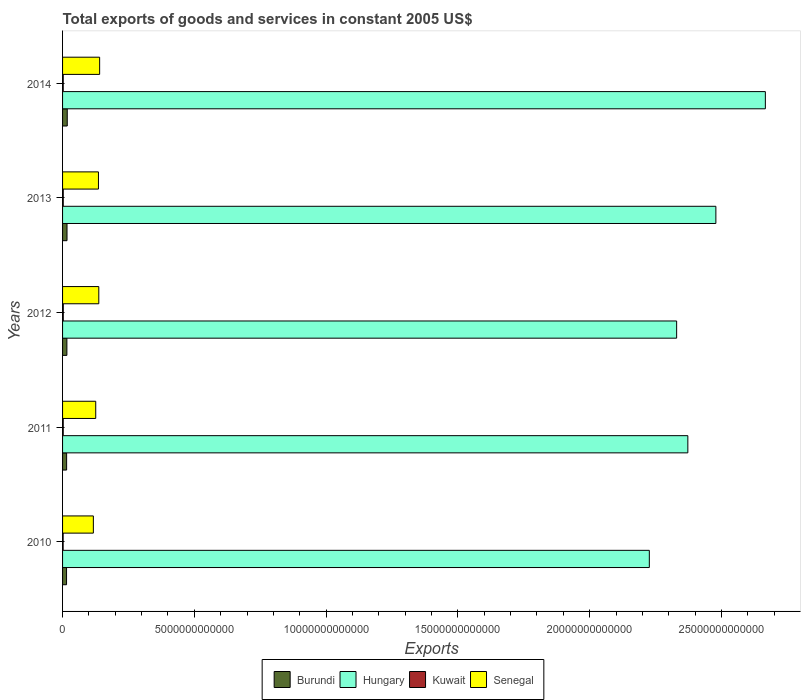How many different coloured bars are there?
Keep it short and to the point. 4. How many groups of bars are there?
Your answer should be compact. 5. Are the number of bars per tick equal to the number of legend labels?
Ensure brevity in your answer.  Yes. Are the number of bars on each tick of the Y-axis equal?
Your answer should be compact. Yes. How many bars are there on the 4th tick from the top?
Keep it short and to the point. 4. What is the label of the 1st group of bars from the top?
Offer a very short reply. 2014. In how many cases, is the number of bars for a given year not equal to the number of legend labels?
Provide a short and direct response. 0. What is the total exports of goods and services in Hungary in 2013?
Your answer should be compact. 2.48e+13. Across all years, what is the maximum total exports of goods and services in Hungary?
Offer a very short reply. 2.67e+13. Across all years, what is the minimum total exports of goods and services in Burundi?
Offer a terse response. 1.51e+11. In which year was the total exports of goods and services in Burundi maximum?
Offer a terse response. 2014. What is the total total exports of goods and services in Hungary in the graph?
Your response must be concise. 1.21e+14. What is the difference between the total exports of goods and services in Hungary in 2012 and that in 2014?
Provide a short and direct response. -3.37e+12. What is the difference between the total exports of goods and services in Burundi in 2011 and the total exports of goods and services in Hungary in 2013?
Offer a terse response. -2.46e+13. What is the average total exports of goods and services in Burundi per year?
Provide a succinct answer. 1.63e+11. In the year 2013, what is the difference between the total exports of goods and services in Burundi and total exports of goods and services in Hungary?
Provide a succinct answer. -2.46e+13. What is the ratio of the total exports of goods and services in Hungary in 2011 to that in 2012?
Offer a very short reply. 1.02. What is the difference between the highest and the second highest total exports of goods and services in Kuwait?
Offer a terse response. 1.08e+09. What is the difference between the highest and the lowest total exports of goods and services in Hungary?
Offer a very short reply. 4.40e+12. In how many years, is the total exports of goods and services in Hungary greater than the average total exports of goods and services in Hungary taken over all years?
Offer a terse response. 2. Is the sum of the total exports of goods and services in Burundi in 2012 and 2014 greater than the maximum total exports of goods and services in Senegal across all years?
Your answer should be very brief. No. Is it the case that in every year, the sum of the total exports of goods and services in Burundi and total exports of goods and services in Senegal is greater than the sum of total exports of goods and services in Hungary and total exports of goods and services in Kuwait?
Provide a short and direct response. No. What does the 3rd bar from the top in 2011 represents?
Your response must be concise. Hungary. What does the 4th bar from the bottom in 2013 represents?
Your answer should be compact. Senegal. How many bars are there?
Your answer should be very brief. 20. Are all the bars in the graph horizontal?
Provide a succinct answer. Yes. What is the difference between two consecutive major ticks on the X-axis?
Ensure brevity in your answer.  5.00e+12. Does the graph contain any zero values?
Offer a terse response. No. Does the graph contain grids?
Keep it short and to the point. No. Where does the legend appear in the graph?
Provide a short and direct response. Bottom center. What is the title of the graph?
Offer a terse response. Total exports of goods and services in constant 2005 US$. What is the label or title of the X-axis?
Your answer should be compact. Exports. What is the label or title of the Y-axis?
Your response must be concise. Years. What is the Exports in Burundi in 2010?
Provide a succinct answer. 1.51e+11. What is the Exports of Hungary in 2010?
Offer a terse response. 2.23e+13. What is the Exports in Kuwait in 2010?
Give a very brief answer. 2.21e+1. What is the Exports in Senegal in 2010?
Offer a very short reply. 1.17e+12. What is the Exports in Burundi in 2011?
Offer a terse response. 1.54e+11. What is the Exports of Hungary in 2011?
Offer a terse response. 2.37e+13. What is the Exports of Kuwait in 2011?
Make the answer very short. 2.52e+1. What is the Exports in Senegal in 2011?
Offer a very short reply. 1.26e+12. What is the Exports of Burundi in 2012?
Your answer should be very brief. 1.64e+11. What is the Exports in Hungary in 2012?
Your answer should be very brief. 2.33e+13. What is the Exports in Kuwait in 2012?
Offer a very short reply. 2.71e+1. What is the Exports in Senegal in 2012?
Keep it short and to the point. 1.37e+12. What is the Exports in Burundi in 2013?
Make the answer very short. 1.69e+11. What is the Exports of Hungary in 2013?
Keep it short and to the point. 2.48e+13. What is the Exports in Kuwait in 2013?
Your answer should be compact. 2.61e+1. What is the Exports in Senegal in 2013?
Your answer should be compact. 1.36e+12. What is the Exports in Burundi in 2014?
Give a very brief answer. 1.78e+11. What is the Exports in Hungary in 2014?
Give a very brief answer. 2.67e+13. What is the Exports of Kuwait in 2014?
Your answer should be compact. 2.52e+1. What is the Exports in Senegal in 2014?
Make the answer very short. 1.41e+12. Across all years, what is the maximum Exports of Burundi?
Your answer should be compact. 1.78e+11. Across all years, what is the maximum Exports of Hungary?
Your response must be concise. 2.67e+13. Across all years, what is the maximum Exports in Kuwait?
Ensure brevity in your answer.  2.71e+1. Across all years, what is the maximum Exports in Senegal?
Offer a terse response. 1.41e+12. Across all years, what is the minimum Exports in Burundi?
Your answer should be compact. 1.51e+11. Across all years, what is the minimum Exports in Hungary?
Give a very brief answer. 2.23e+13. Across all years, what is the minimum Exports of Kuwait?
Make the answer very short. 2.21e+1. Across all years, what is the minimum Exports in Senegal?
Provide a short and direct response. 1.17e+12. What is the total Exports in Burundi in the graph?
Offer a very short reply. 8.16e+11. What is the total Exports of Hungary in the graph?
Provide a short and direct response. 1.21e+14. What is the total Exports of Kuwait in the graph?
Provide a short and direct response. 1.26e+11. What is the total Exports in Senegal in the graph?
Provide a succinct answer. 6.57e+12. What is the difference between the Exports in Burundi in 2010 and that in 2011?
Your response must be concise. -2.64e+09. What is the difference between the Exports in Hungary in 2010 and that in 2011?
Your response must be concise. -1.46e+12. What is the difference between the Exports of Kuwait in 2010 and that in 2011?
Ensure brevity in your answer.  -3.15e+09. What is the difference between the Exports in Senegal in 2010 and that in 2011?
Offer a terse response. -9.03e+1. What is the difference between the Exports in Burundi in 2010 and that in 2012?
Provide a succinct answer. -1.28e+1. What is the difference between the Exports in Hungary in 2010 and that in 2012?
Provide a succinct answer. -1.04e+12. What is the difference between the Exports in Kuwait in 2010 and that in 2012?
Give a very brief answer. -5.08e+09. What is the difference between the Exports in Senegal in 2010 and that in 2012?
Offer a very short reply. -2.06e+11. What is the difference between the Exports of Burundi in 2010 and that in 2013?
Offer a very short reply. -1.77e+1. What is the difference between the Exports in Hungary in 2010 and that in 2013?
Keep it short and to the point. -2.52e+12. What is the difference between the Exports in Kuwait in 2010 and that in 2013?
Offer a terse response. -4.00e+09. What is the difference between the Exports of Senegal in 2010 and that in 2013?
Your response must be concise. -1.93e+11. What is the difference between the Exports in Burundi in 2010 and that in 2014?
Keep it short and to the point. -2.68e+1. What is the difference between the Exports in Hungary in 2010 and that in 2014?
Offer a terse response. -4.40e+12. What is the difference between the Exports of Kuwait in 2010 and that in 2014?
Your answer should be very brief. -3.19e+09. What is the difference between the Exports of Senegal in 2010 and that in 2014?
Your answer should be compact. -2.38e+11. What is the difference between the Exports in Burundi in 2011 and that in 2012?
Ensure brevity in your answer.  -1.01e+1. What is the difference between the Exports of Hungary in 2011 and that in 2012?
Ensure brevity in your answer.  4.25e+11. What is the difference between the Exports of Kuwait in 2011 and that in 2012?
Make the answer very short. -1.94e+09. What is the difference between the Exports of Senegal in 2011 and that in 2012?
Provide a succinct answer. -1.16e+11. What is the difference between the Exports of Burundi in 2011 and that in 2013?
Make the answer very short. -1.50e+1. What is the difference between the Exports in Hungary in 2011 and that in 2013?
Your answer should be compact. -1.06e+12. What is the difference between the Exports in Kuwait in 2011 and that in 2013?
Your response must be concise. -8.54e+08. What is the difference between the Exports of Senegal in 2011 and that in 2013?
Offer a terse response. -1.03e+11. What is the difference between the Exports of Burundi in 2011 and that in 2014?
Give a very brief answer. -2.41e+1. What is the difference between the Exports in Hungary in 2011 and that in 2014?
Provide a short and direct response. -2.94e+12. What is the difference between the Exports in Kuwait in 2011 and that in 2014?
Offer a terse response. -4.82e+07. What is the difference between the Exports in Senegal in 2011 and that in 2014?
Ensure brevity in your answer.  -1.48e+11. What is the difference between the Exports of Burundi in 2012 and that in 2013?
Give a very brief answer. -4.92e+09. What is the difference between the Exports in Hungary in 2012 and that in 2013?
Ensure brevity in your answer.  -1.49e+12. What is the difference between the Exports in Kuwait in 2012 and that in 2013?
Offer a terse response. 1.08e+09. What is the difference between the Exports in Senegal in 2012 and that in 2013?
Offer a terse response. 1.33e+1. What is the difference between the Exports of Burundi in 2012 and that in 2014?
Give a very brief answer. -1.40e+1. What is the difference between the Exports of Hungary in 2012 and that in 2014?
Offer a very short reply. -3.37e+12. What is the difference between the Exports in Kuwait in 2012 and that in 2014?
Offer a terse response. 1.89e+09. What is the difference between the Exports in Senegal in 2012 and that in 2014?
Provide a succinct answer. -3.16e+1. What is the difference between the Exports of Burundi in 2013 and that in 2014?
Your response must be concise. -9.08e+09. What is the difference between the Exports in Hungary in 2013 and that in 2014?
Make the answer very short. -1.88e+12. What is the difference between the Exports in Kuwait in 2013 and that in 2014?
Your answer should be compact. 8.05e+08. What is the difference between the Exports in Senegal in 2013 and that in 2014?
Your answer should be very brief. -4.50e+1. What is the difference between the Exports of Burundi in 2010 and the Exports of Hungary in 2011?
Your answer should be very brief. -2.36e+13. What is the difference between the Exports of Burundi in 2010 and the Exports of Kuwait in 2011?
Your answer should be very brief. 1.26e+11. What is the difference between the Exports in Burundi in 2010 and the Exports in Senegal in 2011?
Provide a short and direct response. -1.11e+12. What is the difference between the Exports of Hungary in 2010 and the Exports of Kuwait in 2011?
Make the answer very short. 2.22e+13. What is the difference between the Exports in Hungary in 2010 and the Exports in Senegal in 2011?
Your answer should be very brief. 2.10e+13. What is the difference between the Exports of Kuwait in 2010 and the Exports of Senegal in 2011?
Give a very brief answer. -1.24e+12. What is the difference between the Exports in Burundi in 2010 and the Exports in Hungary in 2012?
Offer a terse response. -2.31e+13. What is the difference between the Exports in Burundi in 2010 and the Exports in Kuwait in 2012?
Your response must be concise. 1.24e+11. What is the difference between the Exports of Burundi in 2010 and the Exports of Senegal in 2012?
Ensure brevity in your answer.  -1.22e+12. What is the difference between the Exports in Hungary in 2010 and the Exports in Kuwait in 2012?
Provide a short and direct response. 2.22e+13. What is the difference between the Exports of Hungary in 2010 and the Exports of Senegal in 2012?
Make the answer very short. 2.09e+13. What is the difference between the Exports of Kuwait in 2010 and the Exports of Senegal in 2012?
Your answer should be compact. -1.35e+12. What is the difference between the Exports of Burundi in 2010 and the Exports of Hungary in 2013?
Offer a very short reply. -2.46e+13. What is the difference between the Exports of Burundi in 2010 and the Exports of Kuwait in 2013?
Offer a terse response. 1.25e+11. What is the difference between the Exports of Burundi in 2010 and the Exports of Senegal in 2013?
Keep it short and to the point. -1.21e+12. What is the difference between the Exports in Hungary in 2010 and the Exports in Kuwait in 2013?
Make the answer very short. 2.22e+13. What is the difference between the Exports in Hungary in 2010 and the Exports in Senegal in 2013?
Provide a short and direct response. 2.09e+13. What is the difference between the Exports of Kuwait in 2010 and the Exports of Senegal in 2013?
Your answer should be compact. -1.34e+12. What is the difference between the Exports of Burundi in 2010 and the Exports of Hungary in 2014?
Provide a succinct answer. -2.65e+13. What is the difference between the Exports in Burundi in 2010 and the Exports in Kuwait in 2014?
Ensure brevity in your answer.  1.26e+11. What is the difference between the Exports of Burundi in 2010 and the Exports of Senegal in 2014?
Your answer should be very brief. -1.26e+12. What is the difference between the Exports of Hungary in 2010 and the Exports of Kuwait in 2014?
Keep it short and to the point. 2.22e+13. What is the difference between the Exports in Hungary in 2010 and the Exports in Senegal in 2014?
Keep it short and to the point. 2.09e+13. What is the difference between the Exports in Kuwait in 2010 and the Exports in Senegal in 2014?
Provide a succinct answer. -1.38e+12. What is the difference between the Exports of Burundi in 2011 and the Exports of Hungary in 2012?
Your response must be concise. -2.31e+13. What is the difference between the Exports in Burundi in 2011 and the Exports in Kuwait in 2012?
Make the answer very short. 1.27e+11. What is the difference between the Exports of Burundi in 2011 and the Exports of Senegal in 2012?
Your answer should be very brief. -1.22e+12. What is the difference between the Exports of Hungary in 2011 and the Exports of Kuwait in 2012?
Make the answer very short. 2.37e+13. What is the difference between the Exports of Hungary in 2011 and the Exports of Senegal in 2012?
Your answer should be very brief. 2.24e+13. What is the difference between the Exports in Kuwait in 2011 and the Exports in Senegal in 2012?
Keep it short and to the point. -1.35e+12. What is the difference between the Exports of Burundi in 2011 and the Exports of Hungary in 2013?
Offer a terse response. -2.46e+13. What is the difference between the Exports of Burundi in 2011 and the Exports of Kuwait in 2013?
Make the answer very short. 1.28e+11. What is the difference between the Exports of Burundi in 2011 and the Exports of Senegal in 2013?
Your answer should be very brief. -1.21e+12. What is the difference between the Exports of Hungary in 2011 and the Exports of Kuwait in 2013?
Offer a terse response. 2.37e+13. What is the difference between the Exports in Hungary in 2011 and the Exports in Senegal in 2013?
Provide a short and direct response. 2.24e+13. What is the difference between the Exports in Kuwait in 2011 and the Exports in Senegal in 2013?
Offer a very short reply. -1.34e+12. What is the difference between the Exports in Burundi in 2011 and the Exports in Hungary in 2014?
Provide a succinct answer. -2.65e+13. What is the difference between the Exports in Burundi in 2011 and the Exports in Kuwait in 2014?
Ensure brevity in your answer.  1.29e+11. What is the difference between the Exports in Burundi in 2011 and the Exports in Senegal in 2014?
Your response must be concise. -1.25e+12. What is the difference between the Exports in Hungary in 2011 and the Exports in Kuwait in 2014?
Ensure brevity in your answer.  2.37e+13. What is the difference between the Exports of Hungary in 2011 and the Exports of Senegal in 2014?
Your answer should be compact. 2.23e+13. What is the difference between the Exports of Kuwait in 2011 and the Exports of Senegal in 2014?
Offer a very short reply. -1.38e+12. What is the difference between the Exports in Burundi in 2012 and the Exports in Hungary in 2013?
Give a very brief answer. -2.46e+13. What is the difference between the Exports in Burundi in 2012 and the Exports in Kuwait in 2013?
Make the answer very short. 1.38e+11. What is the difference between the Exports of Burundi in 2012 and the Exports of Senegal in 2013?
Offer a terse response. -1.20e+12. What is the difference between the Exports in Hungary in 2012 and the Exports in Kuwait in 2013?
Offer a very short reply. 2.33e+13. What is the difference between the Exports in Hungary in 2012 and the Exports in Senegal in 2013?
Make the answer very short. 2.19e+13. What is the difference between the Exports in Kuwait in 2012 and the Exports in Senegal in 2013?
Provide a succinct answer. -1.33e+12. What is the difference between the Exports of Burundi in 2012 and the Exports of Hungary in 2014?
Give a very brief answer. -2.65e+13. What is the difference between the Exports of Burundi in 2012 and the Exports of Kuwait in 2014?
Provide a succinct answer. 1.39e+11. What is the difference between the Exports of Burundi in 2012 and the Exports of Senegal in 2014?
Give a very brief answer. -1.24e+12. What is the difference between the Exports of Hungary in 2012 and the Exports of Kuwait in 2014?
Offer a very short reply. 2.33e+13. What is the difference between the Exports in Hungary in 2012 and the Exports in Senegal in 2014?
Give a very brief answer. 2.19e+13. What is the difference between the Exports in Kuwait in 2012 and the Exports in Senegal in 2014?
Offer a terse response. -1.38e+12. What is the difference between the Exports in Burundi in 2013 and the Exports in Hungary in 2014?
Offer a terse response. -2.65e+13. What is the difference between the Exports in Burundi in 2013 and the Exports in Kuwait in 2014?
Your response must be concise. 1.44e+11. What is the difference between the Exports of Burundi in 2013 and the Exports of Senegal in 2014?
Your answer should be compact. -1.24e+12. What is the difference between the Exports in Hungary in 2013 and the Exports in Kuwait in 2014?
Provide a short and direct response. 2.48e+13. What is the difference between the Exports in Hungary in 2013 and the Exports in Senegal in 2014?
Offer a very short reply. 2.34e+13. What is the difference between the Exports in Kuwait in 2013 and the Exports in Senegal in 2014?
Your answer should be very brief. -1.38e+12. What is the average Exports in Burundi per year?
Give a very brief answer. 1.63e+11. What is the average Exports of Hungary per year?
Make the answer very short. 2.41e+13. What is the average Exports of Kuwait per year?
Your response must be concise. 2.51e+1. What is the average Exports in Senegal per year?
Provide a succinct answer. 1.31e+12. In the year 2010, what is the difference between the Exports in Burundi and Exports in Hungary?
Make the answer very short. -2.21e+13. In the year 2010, what is the difference between the Exports in Burundi and Exports in Kuwait?
Provide a succinct answer. 1.29e+11. In the year 2010, what is the difference between the Exports in Burundi and Exports in Senegal?
Your response must be concise. -1.02e+12. In the year 2010, what is the difference between the Exports in Hungary and Exports in Kuwait?
Make the answer very short. 2.22e+13. In the year 2010, what is the difference between the Exports of Hungary and Exports of Senegal?
Ensure brevity in your answer.  2.11e+13. In the year 2010, what is the difference between the Exports of Kuwait and Exports of Senegal?
Ensure brevity in your answer.  -1.15e+12. In the year 2011, what is the difference between the Exports of Burundi and Exports of Hungary?
Offer a very short reply. -2.36e+13. In the year 2011, what is the difference between the Exports in Burundi and Exports in Kuwait?
Your response must be concise. 1.29e+11. In the year 2011, what is the difference between the Exports of Burundi and Exports of Senegal?
Offer a terse response. -1.10e+12. In the year 2011, what is the difference between the Exports of Hungary and Exports of Kuwait?
Keep it short and to the point. 2.37e+13. In the year 2011, what is the difference between the Exports of Hungary and Exports of Senegal?
Provide a short and direct response. 2.25e+13. In the year 2011, what is the difference between the Exports in Kuwait and Exports in Senegal?
Your answer should be compact. -1.23e+12. In the year 2012, what is the difference between the Exports in Burundi and Exports in Hungary?
Offer a terse response. -2.31e+13. In the year 2012, what is the difference between the Exports in Burundi and Exports in Kuwait?
Provide a short and direct response. 1.37e+11. In the year 2012, what is the difference between the Exports in Burundi and Exports in Senegal?
Offer a very short reply. -1.21e+12. In the year 2012, what is the difference between the Exports in Hungary and Exports in Kuwait?
Offer a terse response. 2.33e+13. In the year 2012, what is the difference between the Exports of Hungary and Exports of Senegal?
Ensure brevity in your answer.  2.19e+13. In the year 2012, what is the difference between the Exports of Kuwait and Exports of Senegal?
Your answer should be compact. -1.35e+12. In the year 2013, what is the difference between the Exports of Burundi and Exports of Hungary?
Give a very brief answer. -2.46e+13. In the year 2013, what is the difference between the Exports of Burundi and Exports of Kuwait?
Your response must be concise. 1.43e+11. In the year 2013, what is the difference between the Exports in Burundi and Exports in Senegal?
Keep it short and to the point. -1.19e+12. In the year 2013, what is the difference between the Exports in Hungary and Exports in Kuwait?
Give a very brief answer. 2.48e+13. In the year 2013, what is the difference between the Exports of Hungary and Exports of Senegal?
Give a very brief answer. 2.34e+13. In the year 2013, what is the difference between the Exports in Kuwait and Exports in Senegal?
Provide a succinct answer. -1.34e+12. In the year 2014, what is the difference between the Exports of Burundi and Exports of Hungary?
Give a very brief answer. -2.65e+13. In the year 2014, what is the difference between the Exports in Burundi and Exports in Kuwait?
Your response must be concise. 1.53e+11. In the year 2014, what is the difference between the Exports in Burundi and Exports in Senegal?
Your response must be concise. -1.23e+12. In the year 2014, what is the difference between the Exports of Hungary and Exports of Kuwait?
Offer a very short reply. 2.66e+13. In the year 2014, what is the difference between the Exports of Hungary and Exports of Senegal?
Your answer should be compact. 2.53e+13. In the year 2014, what is the difference between the Exports in Kuwait and Exports in Senegal?
Offer a terse response. -1.38e+12. What is the ratio of the Exports in Burundi in 2010 to that in 2011?
Ensure brevity in your answer.  0.98. What is the ratio of the Exports in Hungary in 2010 to that in 2011?
Ensure brevity in your answer.  0.94. What is the ratio of the Exports in Kuwait in 2010 to that in 2011?
Keep it short and to the point. 0.88. What is the ratio of the Exports in Senegal in 2010 to that in 2011?
Offer a very short reply. 0.93. What is the ratio of the Exports in Burundi in 2010 to that in 2012?
Your answer should be compact. 0.92. What is the ratio of the Exports of Hungary in 2010 to that in 2012?
Provide a succinct answer. 0.96. What is the ratio of the Exports in Kuwait in 2010 to that in 2012?
Offer a terse response. 0.81. What is the ratio of the Exports in Senegal in 2010 to that in 2012?
Your answer should be very brief. 0.85. What is the ratio of the Exports of Burundi in 2010 to that in 2013?
Your answer should be compact. 0.9. What is the ratio of the Exports in Hungary in 2010 to that in 2013?
Provide a succinct answer. 0.9. What is the ratio of the Exports of Kuwait in 2010 to that in 2013?
Give a very brief answer. 0.85. What is the ratio of the Exports in Senegal in 2010 to that in 2013?
Your response must be concise. 0.86. What is the ratio of the Exports in Burundi in 2010 to that in 2014?
Provide a succinct answer. 0.85. What is the ratio of the Exports in Hungary in 2010 to that in 2014?
Keep it short and to the point. 0.83. What is the ratio of the Exports of Kuwait in 2010 to that in 2014?
Offer a very short reply. 0.87. What is the ratio of the Exports of Senegal in 2010 to that in 2014?
Give a very brief answer. 0.83. What is the ratio of the Exports of Burundi in 2011 to that in 2012?
Provide a short and direct response. 0.94. What is the ratio of the Exports of Hungary in 2011 to that in 2012?
Your response must be concise. 1.02. What is the ratio of the Exports of Kuwait in 2011 to that in 2012?
Keep it short and to the point. 0.93. What is the ratio of the Exports of Senegal in 2011 to that in 2012?
Provide a succinct answer. 0.92. What is the ratio of the Exports of Burundi in 2011 to that in 2013?
Provide a short and direct response. 0.91. What is the ratio of the Exports in Hungary in 2011 to that in 2013?
Offer a terse response. 0.96. What is the ratio of the Exports of Kuwait in 2011 to that in 2013?
Make the answer very short. 0.97. What is the ratio of the Exports of Senegal in 2011 to that in 2013?
Give a very brief answer. 0.92. What is the ratio of the Exports in Burundi in 2011 to that in 2014?
Your response must be concise. 0.86. What is the ratio of the Exports in Hungary in 2011 to that in 2014?
Offer a terse response. 0.89. What is the ratio of the Exports in Kuwait in 2011 to that in 2014?
Make the answer very short. 1. What is the ratio of the Exports in Senegal in 2011 to that in 2014?
Make the answer very short. 0.9. What is the ratio of the Exports of Burundi in 2012 to that in 2013?
Offer a very short reply. 0.97. What is the ratio of the Exports of Hungary in 2012 to that in 2013?
Make the answer very short. 0.94. What is the ratio of the Exports in Kuwait in 2012 to that in 2013?
Ensure brevity in your answer.  1.04. What is the ratio of the Exports of Senegal in 2012 to that in 2013?
Your answer should be compact. 1.01. What is the ratio of the Exports in Burundi in 2012 to that in 2014?
Offer a terse response. 0.92. What is the ratio of the Exports in Hungary in 2012 to that in 2014?
Make the answer very short. 0.87. What is the ratio of the Exports of Kuwait in 2012 to that in 2014?
Give a very brief answer. 1.07. What is the ratio of the Exports in Senegal in 2012 to that in 2014?
Make the answer very short. 0.98. What is the ratio of the Exports in Burundi in 2013 to that in 2014?
Provide a short and direct response. 0.95. What is the ratio of the Exports in Hungary in 2013 to that in 2014?
Offer a very short reply. 0.93. What is the ratio of the Exports in Kuwait in 2013 to that in 2014?
Offer a very short reply. 1.03. What is the difference between the highest and the second highest Exports in Burundi?
Your answer should be very brief. 9.08e+09. What is the difference between the highest and the second highest Exports in Hungary?
Make the answer very short. 1.88e+12. What is the difference between the highest and the second highest Exports of Kuwait?
Offer a very short reply. 1.08e+09. What is the difference between the highest and the second highest Exports in Senegal?
Offer a terse response. 3.16e+1. What is the difference between the highest and the lowest Exports of Burundi?
Offer a very short reply. 2.68e+1. What is the difference between the highest and the lowest Exports of Hungary?
Provide a short and direct response. 4.40e+12. What is the difference between the highest and the lowest Exports in Kuwait?
Keep it short and to the point. 5.08e+09. What is the difference between the highest and the lowest Exports in Senegal?
Give a very brief answer. 2.38e+11. 